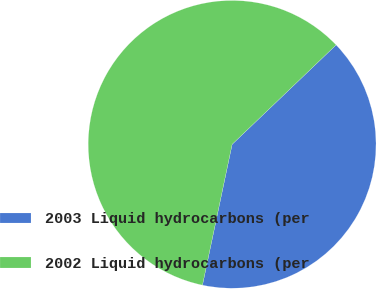Convert chart. <chart><loc_0><loc_0><loc_500><loc_500><pie_chart><fcel>2003 Liquid hydrocarbons (per<fcel>2002 Liquid hydrocarbons (per<nl><fcel>40.45%<fcel>59.55%<nl></chart> 